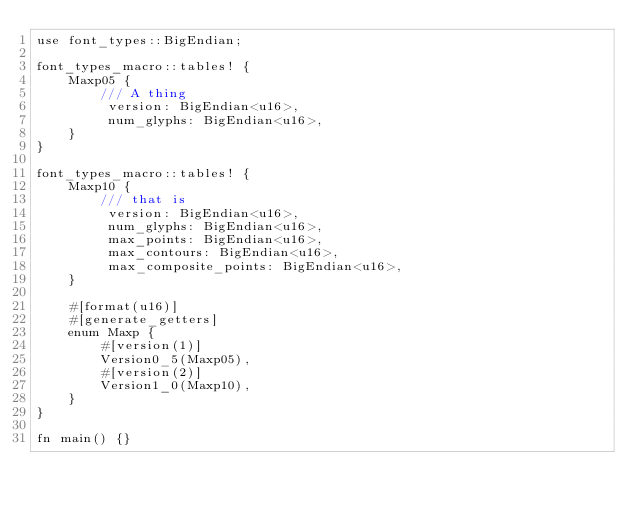Convert code to text. <code><loc_0><loc_0><loc_500><loc_500><_Rust_>use font_types::BigEndian;

font_types_macro::tables! {
    Maxp05 {
        /// A thing
         version: BigEndian<u16>,
         num_glyphs: BigEndian<u16>,
    }
}

font_types_macro::tables! {
    Maxp10 {
        /// that is
         version: BigEndian<u16>,
         num_glyphs: BigEndian<u16>,
         max_points: BigEndian<u16>,
         max_contours: BigEndian<u16>,
         max_composite_points: BigEndian<u16>,
    }

    #[format(u16)]
    #[generate_getters]
    enum Maxp {
        #[version(1)]
        Version0_5(Maxp05),
        #[version(2)]
        Version1_0(Maxp10),
    }
}

fn main() {}
</code> 